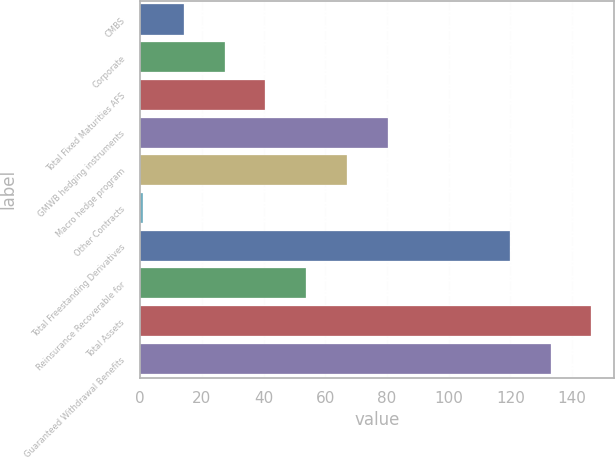Convert chart to OTSL. <chart><loc_0><loc_0><loc_500><loc_500><bar_chart><fcel>CMBS<fcel>Corporate<fcel>Total Fixed Maturities AFS<fcel>GMWB hedging instruments<fcel>Macro hedge program<fcel>Other Contracts<fcel>Total Freestanding Derivatives<fcel>Reinsurance Recoverable for<fcel>Total Assets<fcel>Guaranteed Withdrawal Benefits<nl><fcel>14.2<fcel>27.4<fcel>40.6<fcel>80.2<fcel>67<fcel>1<fcel>119.8<fcel>53.8<fcel>146.2<fcel>133<nl></chart> 